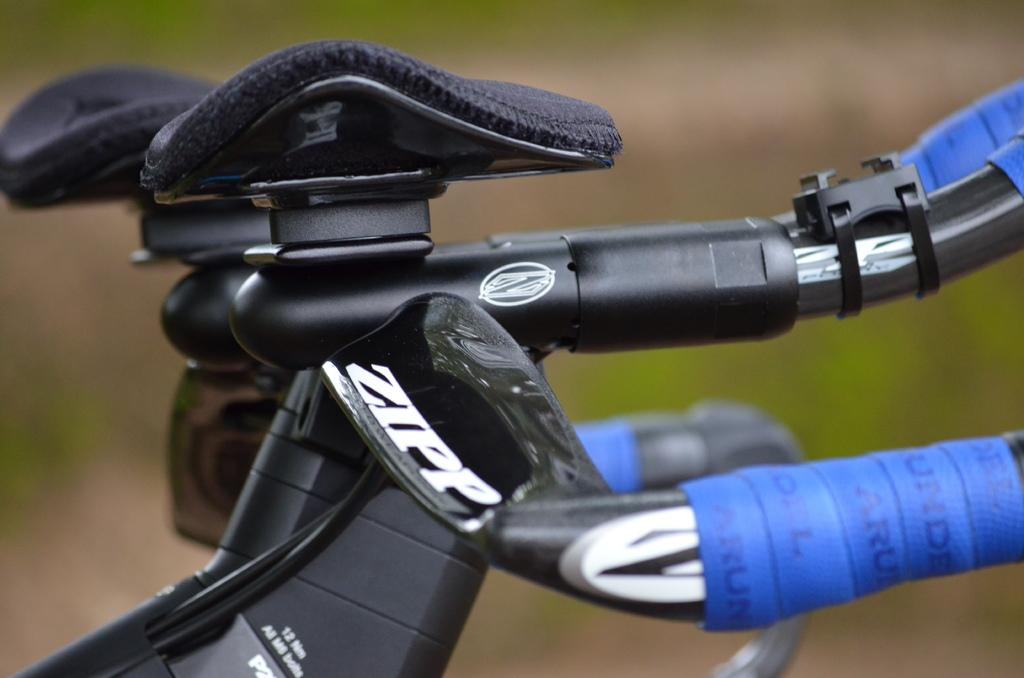What object is the main focus of the image? The main focus of the image is the handle of a bicycle. Can you describe the background of the image? The background of the image is blurred. What type of sugar is being used in the hospital depicted in the image? There is no hospital or sugar present in the image; it only features the handle of a bicycle and a blurred background. 